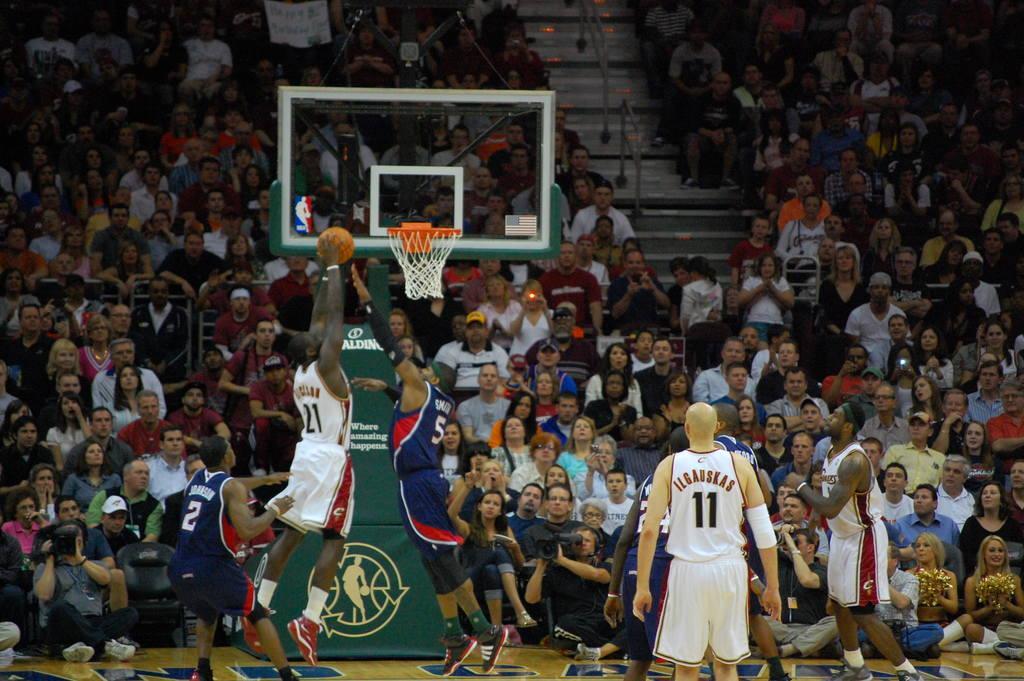Describe this image in one or two sentences. In this image in the center there are persons playing a game and in the background there are persons sitting and there are persons sitting and holding cameras in their hands. On the top there is a basketball net. 